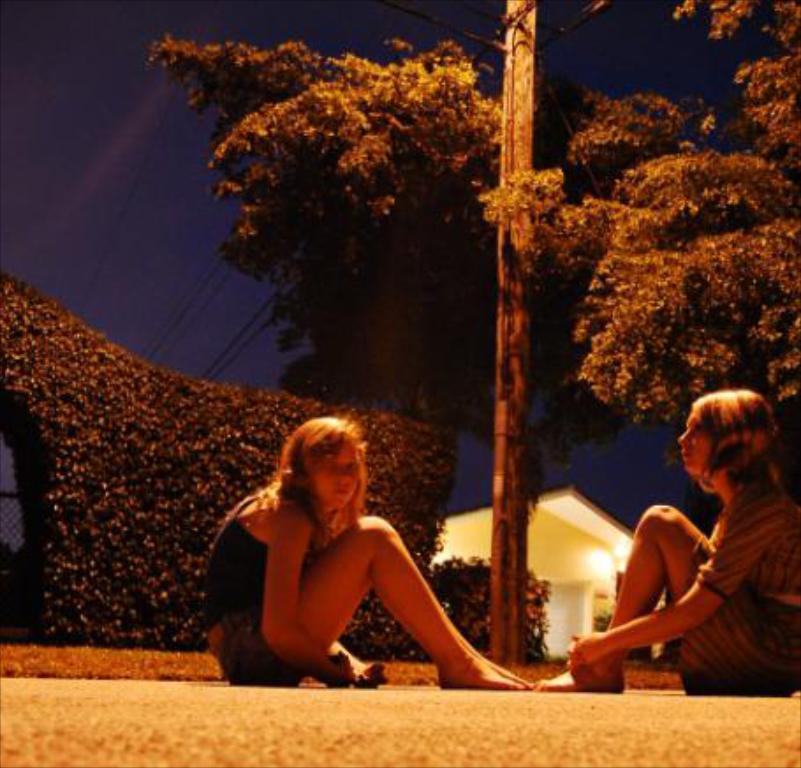Describe this image in one or two sentences. In this image, we can see two persons wearing clothes and sitting on the road. There is a street pole and branch in the middle of the image. There are some plants on the left side of the image. There is a sky at the top of the image. There is a house in the bottom right of the image. 